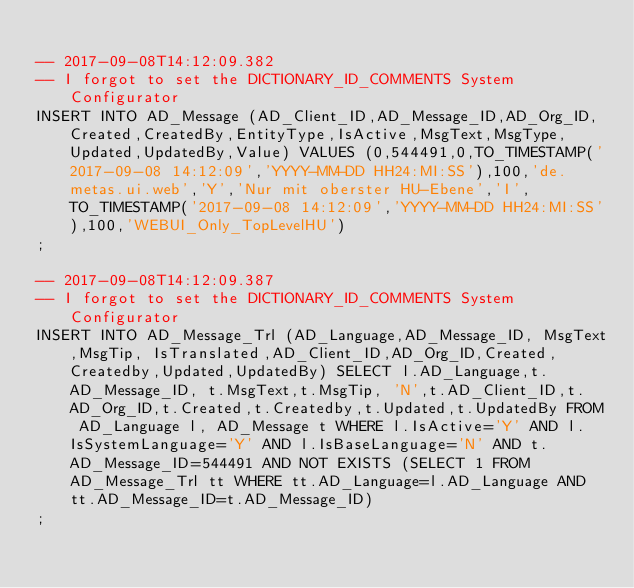<code> <loc_0><loc_0><loc_500><loc_500><_SQL_>
-- 2017-09-08T14:12:09.382
-- I forgot to set the DICTIONARY_ID_COMMENTS System Configurator
INSERT INTO AD_Message (AD_Client_ID,AD_Message_ID,AD_Org_ID,Created,CreatedBy,EntityType,IsActive,MsgText,MsgType,Updated,UpdatedBy,Value) VALUES (0,544491,0,TO_TIMESTAMP('2017-09-08 14:12:09','YYYY-MM-DD HH24:MI:SS'),100,'de.metas.ui.web','Y','Nur mit oberster HU-Ebene','I',TO_TIMESTAMP('2017-09-08 14:12:09','YYYY-MM-DD HH24:MI:SS'),100,'WEBUI_Only_TopLevelHU')
;

-- 2017-09-08T14:12:09.387
-- I forgot to set the DICTIONARY_ID_COMMENTS System Configurator
INSERT INTO AD_Message_Trl (AD_Language,AD_Message_ID, MsgText,MsgTip, IsTranslated,AD_Client_ID,AD_Org_ID,Created,Createdby,Updated,UpdatedBy) SELECT l.AD_Language,t.AD_Message_ID, t.MsgText,t.MsgTip, 'N',t.AD_Client_ID,t.AD_Org_ID,t.Created,t.Createdby,t.Updated,t.UpdatedBy FROM AD_Language l, AD_Message t WHERE l.IsActive='Y' AND l.IsSystemLanguage='Y' AND l.IsBaseLanguage='N' AND t.AD_Message_ID=544491 AND NOT EXISTS (SELECT 1 FROM AD_Message_Trl tt WHERE tt.AD_Language=l.AD_Language AND tt.AD_Message_ID=t.AD_Message_ID)
;

</code> 